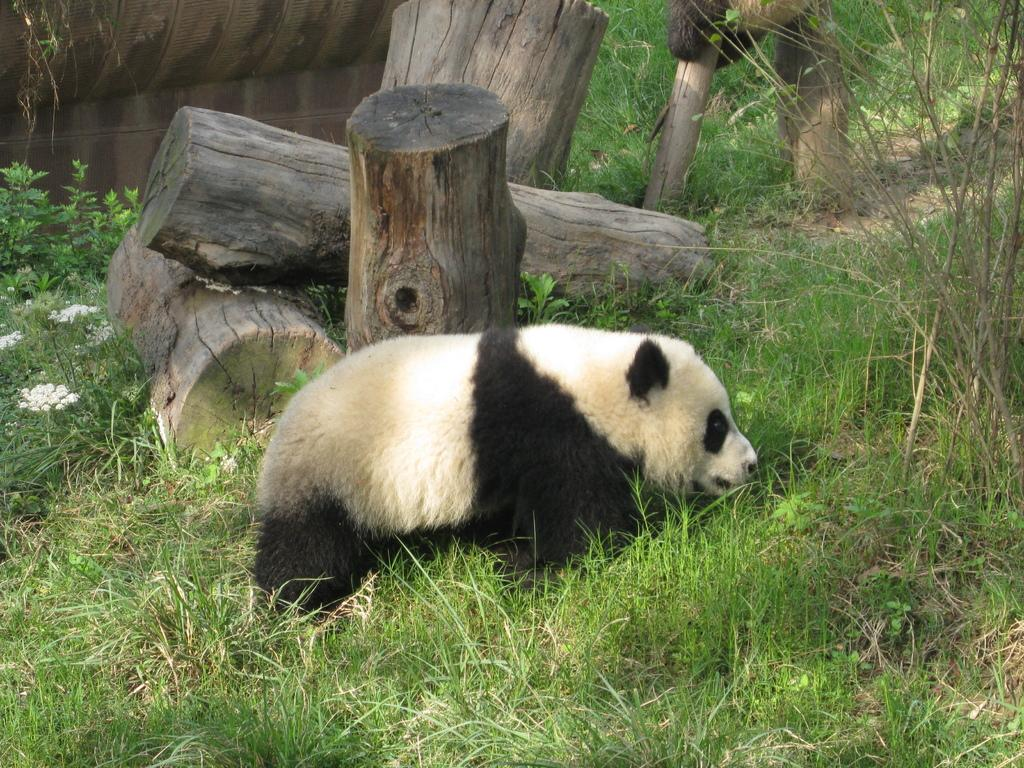What animal is featured in the image? There is a panda in the image. What is the panda doing in the image? The panda is laying on the grass. What can be seen behind the panda? There are wooden logs behind the panda. What type of power source is visible in the image? There is no power source visible in the image; it features a panda laying on the grass with wooden logs behind it. 